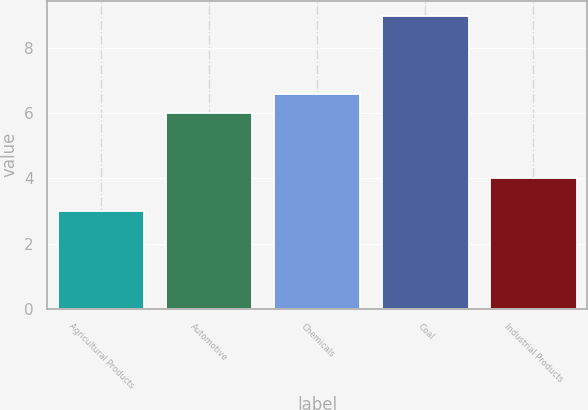<chart> <loc_0><loc_0><loc_500><loc_500><bar_chart><fcel>Agricultural Products<fcel>Automotive<fcel>Chemicals<fcel>Coal<fcel>Industrial Products<nl><fcel>3<fcel>6<fcel>6.6<fcel>9<fcel>4<nl></chart> 